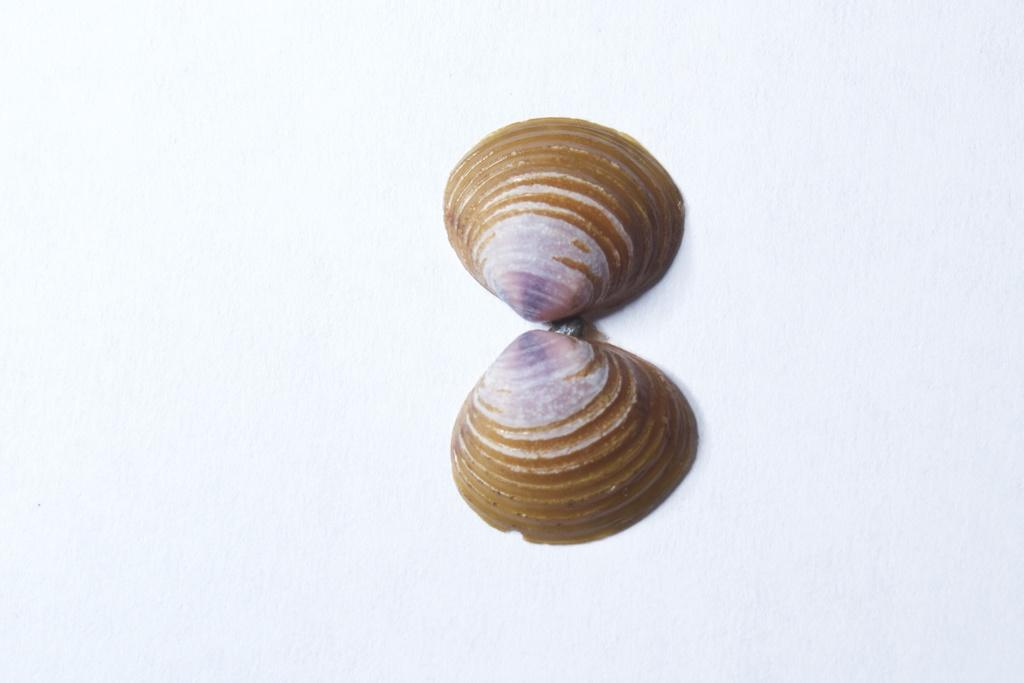What objects can be seen in the image? There are sea shells in the image. What is the color of the surface on which the sea shells are placed? The sea shells are kept on a white surface. What type of poison is being used to clean the sea shells in the image? There is no poison present in the image, and the sea shells are not being cleaned. 